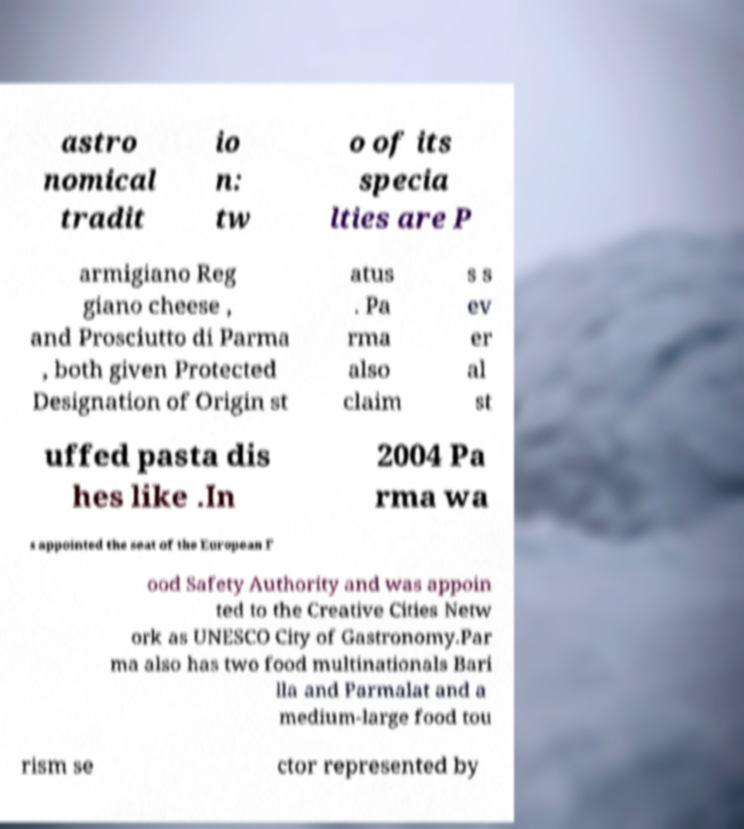Can you accurately transcribe the text from the provided image for me? astro nomical tradit io n: tw o of its specia lties are P armigiano Reg giano cheese , and Prosciutto di Parma , both given Protected Designation of Origin st atus . Pa rma also claim s s ev er al st uffed pasta dis hes like .In 2004 Pa rma wa s appointed the seat of the European F ood Safety Authority and was appoin ted to the Creative Cities Netw ork as UNESCO City of Gastronomy.Par ma also has two food multinationals Bari lla and Parmalat and a medium-large food tou rism se ctor represented by 